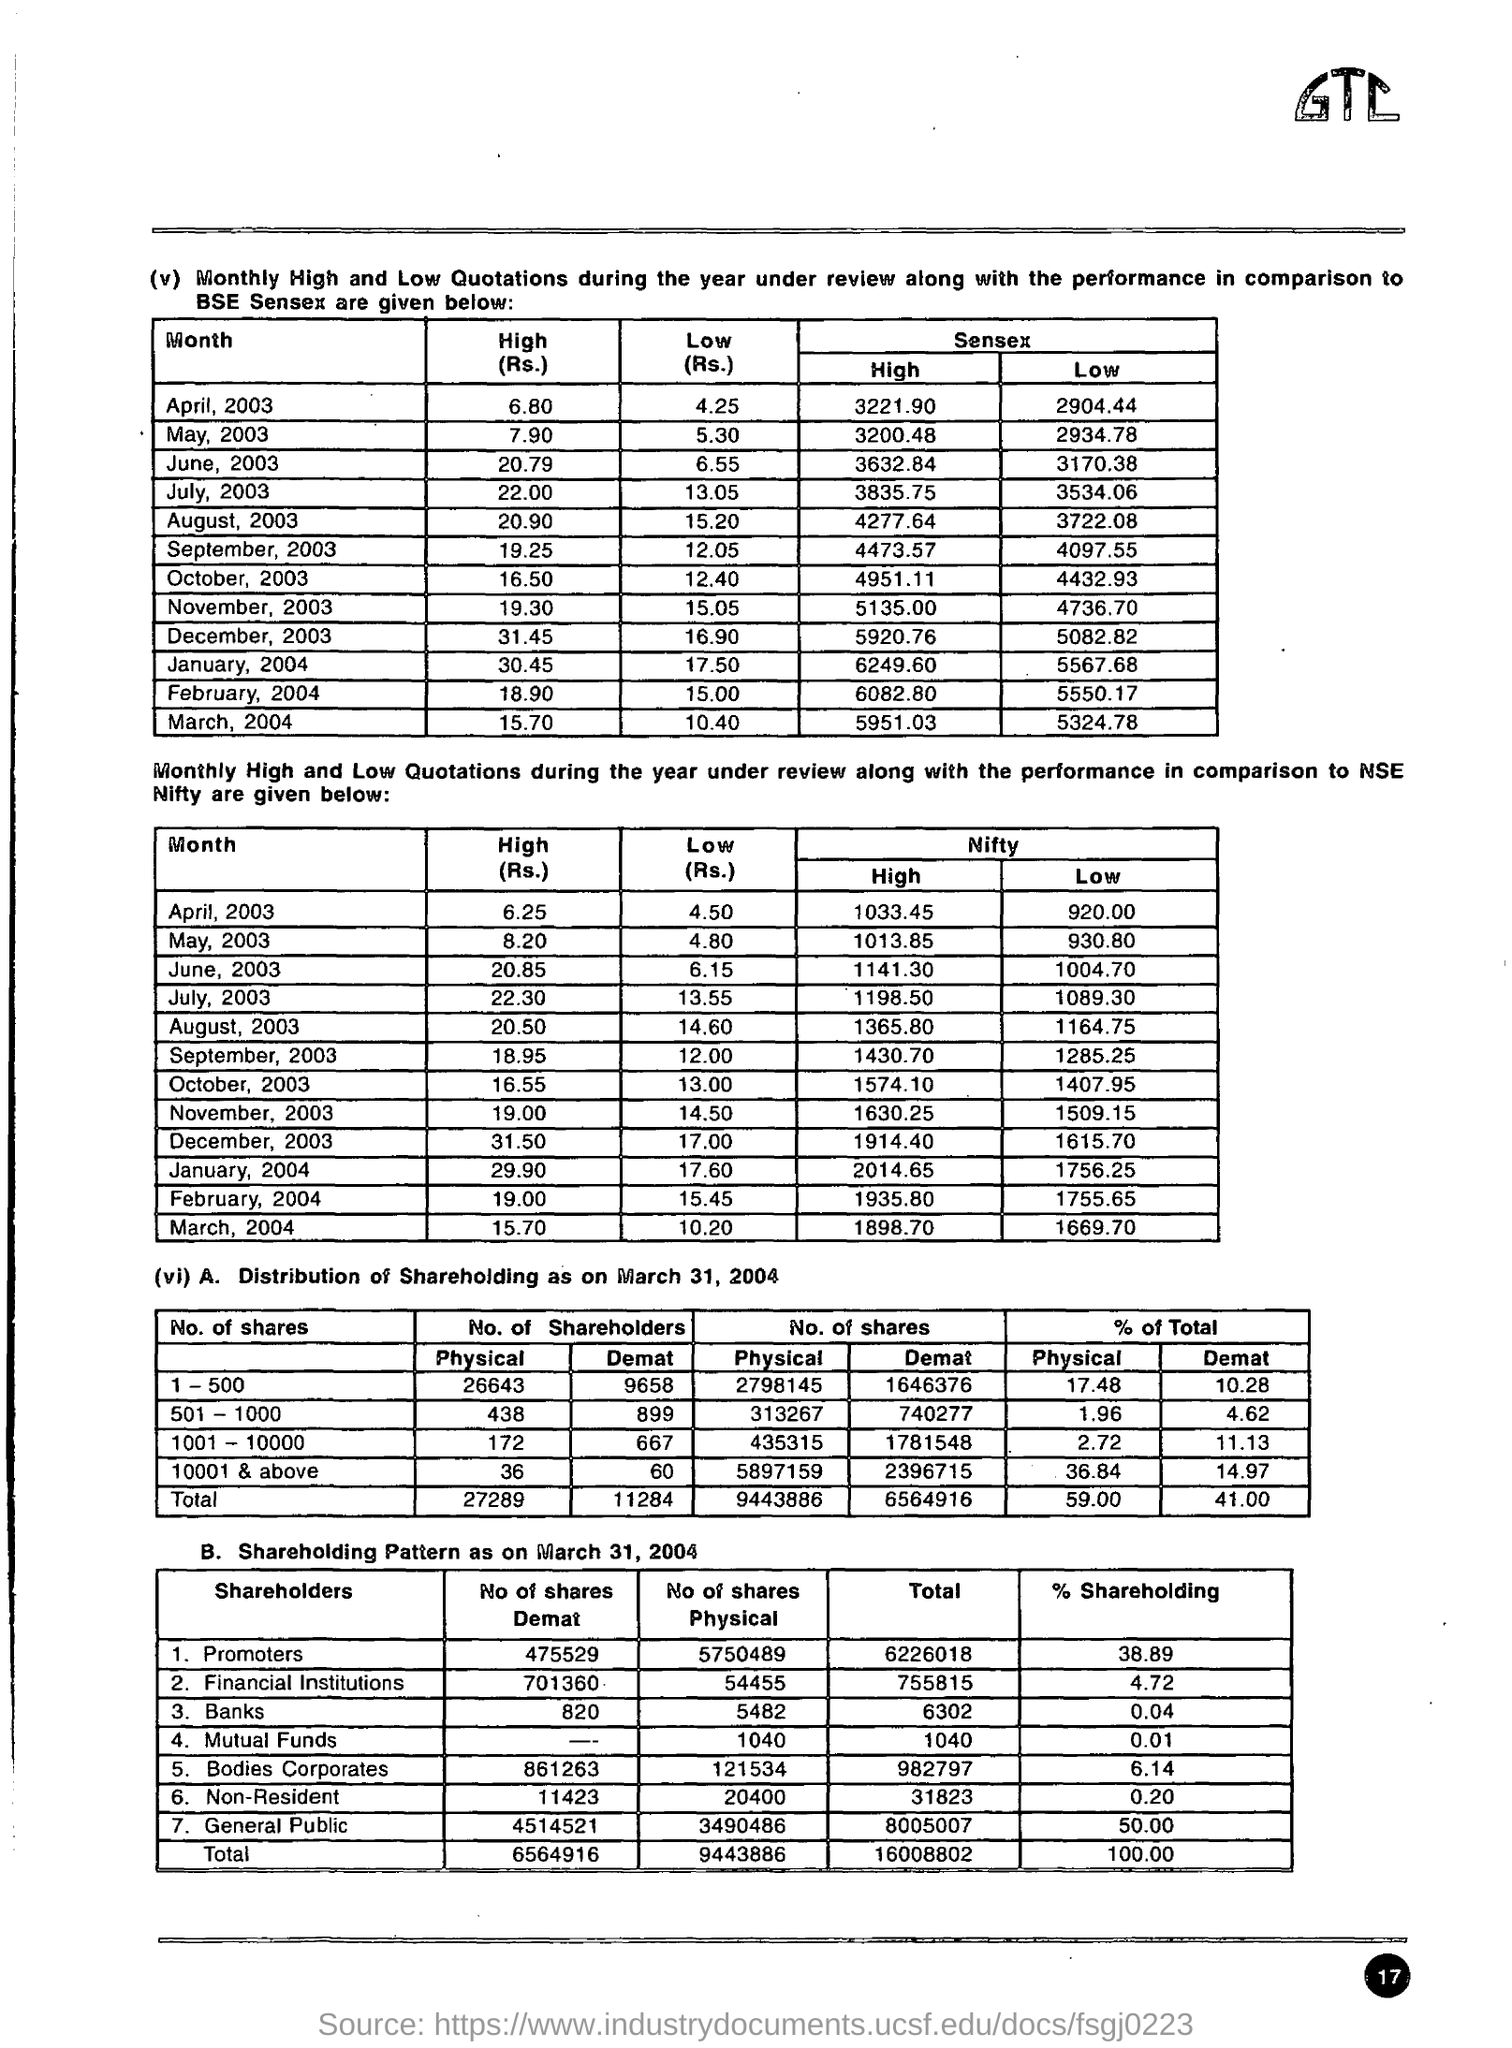Highlight a few significant elements in this photo. On June 30, 2003, the low value of BSE SENSEX was 3170.38. On August 2003, the low value of BSE SENSEX was recorded at 3722.08. The BSE SENSEX experienced a low point of 2904.44 in April 2003. The value of BSE SENSEX in July 2003 was 3835.75. In May 2003, the high value in the BSE Sensex was 3200.48. 